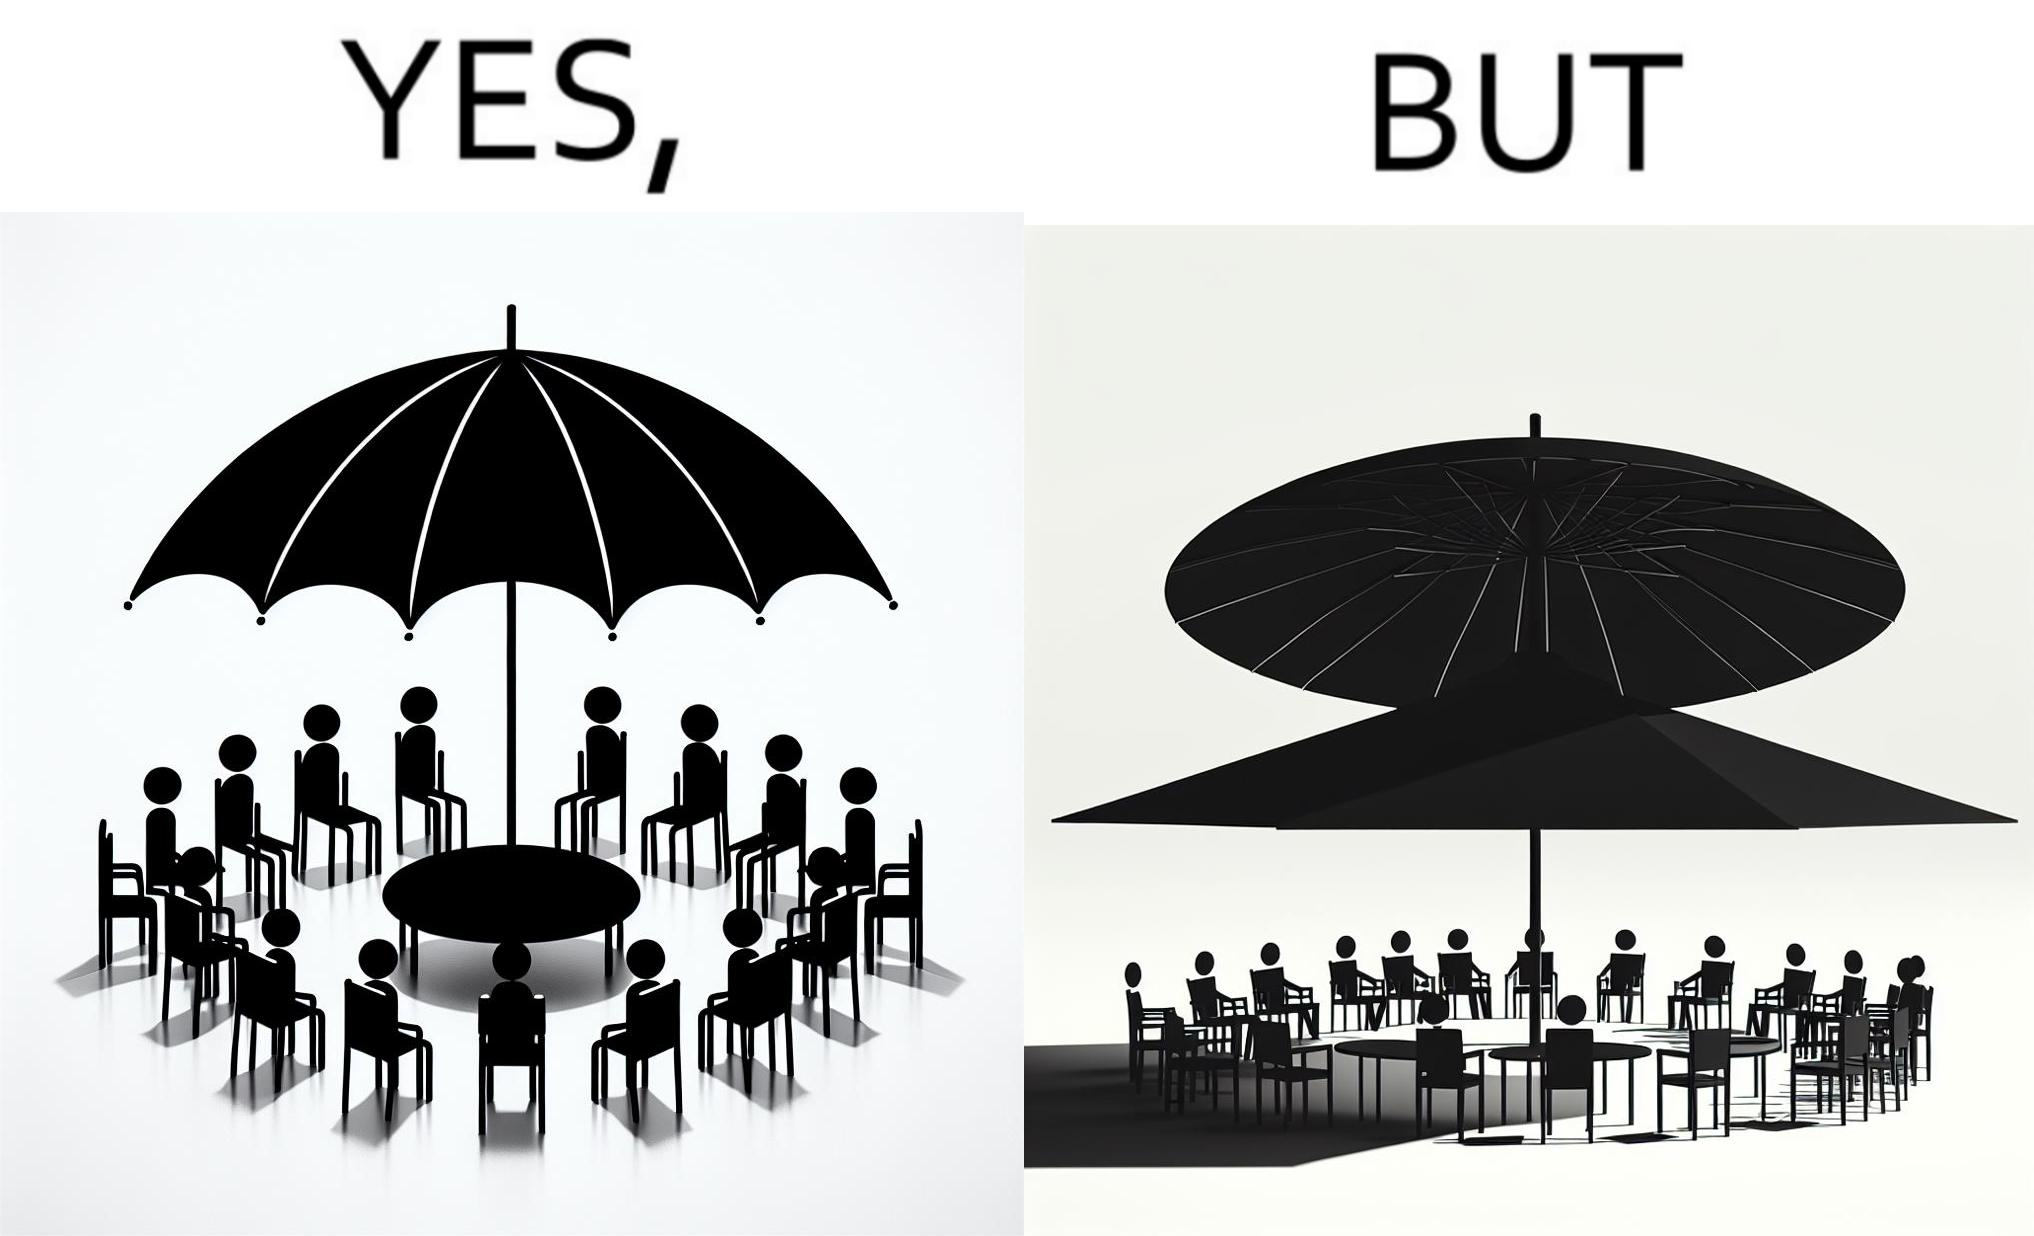Why is this image considered satirical? The image is ironical, as the umbrella is meant to provide shadow in the area where the chairs are present, but due to the orientation of the rays of the sun, all the chairs are in sunlight, and the umbrella is of no use in this situation. 